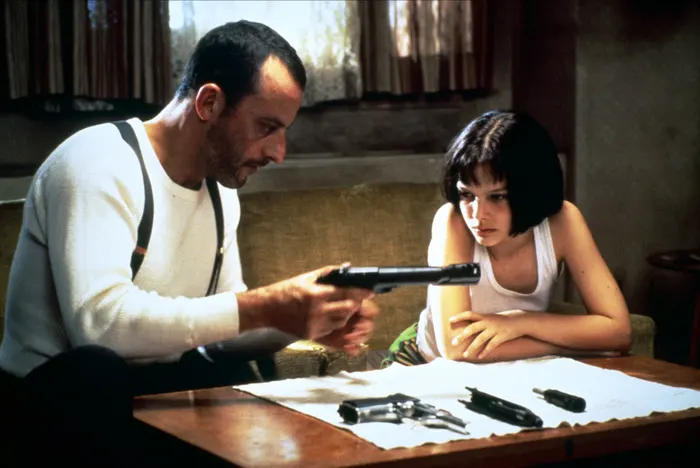If a magical element were introduced in this scene, how would it change the dynamics? Introducing a magical element, such as a mystical artifact or a spellbook on the table, would greatly change the dynamics of the scene. Léon might be shown carefully handling the artifact, with glowing symbols indicating its power, while Mathilda could be depicted learning to harness a new, magical skill. This shift would add a layer of fantasy to their world, implying that their mission involves supernatural forces. The tension in their expressions would now also reflect the weight and danger of dealing with magic, adding an intriguing twist to their already complex relationship. Imagine this image as the cover of a graphic novel. How would you design the cover to capture the essence of the scene? For the cover of a graphic novel, I would design a high-contrast, stylized image that highlights the intense, emotional connection between Léon and Mathilda. They would be positioned exactly as they are in the image, with Léon focused on the gun and Mathilda watching intently. The background would be in muted tones to draw attention to the characters. The title of the graphic novel, possibly rendered in a gritty, bold font, would be placed at the top or bottom. To enhance the dramatic effect, shadows would be used creatively to highlight the danger and intimacy of the scene. Additional elements like subtle bullet motifs or ripped paper could be integrated to convey the themes of violence and tension integral to their story. 